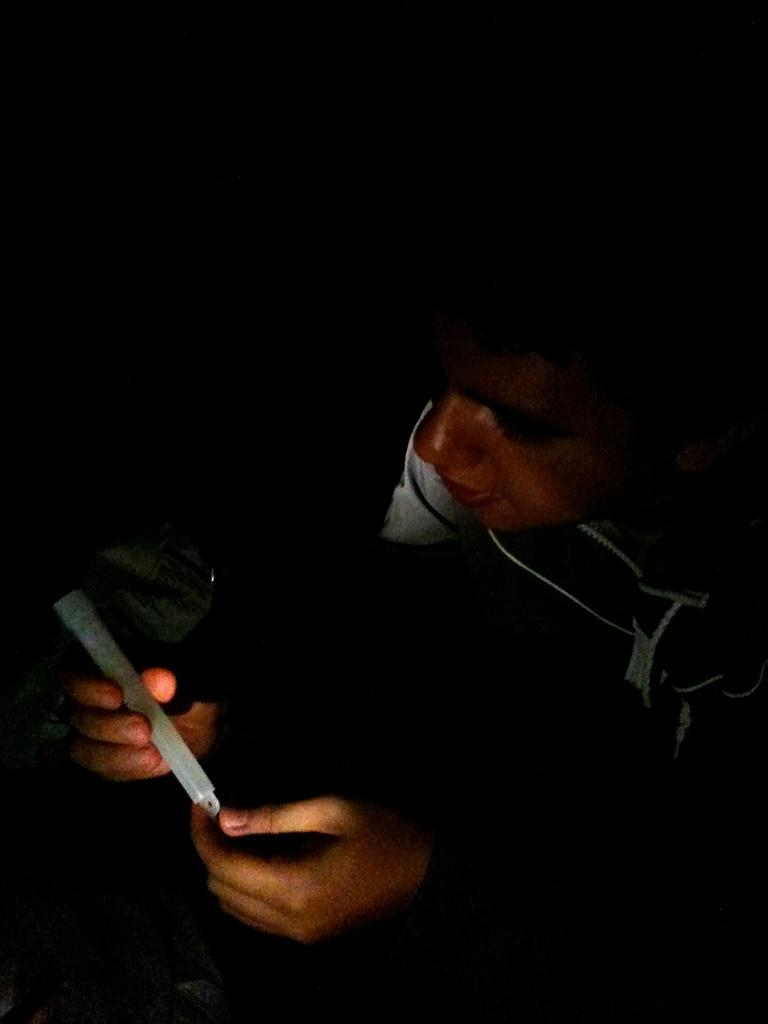What is present in the image? There is a man in the image. What is the man looking at? The man is looking at a candle. What is the man holding in his hand? The candle is in the man's hand. What type of yoke is the man wearing in the image? There is no yoke present in the image, and the man is not wearing any apparel related to a yoke. What type of yam is the man holding in his hand instead of the candle? There is no yam present in the image; the man is holding a candle in his hand. 